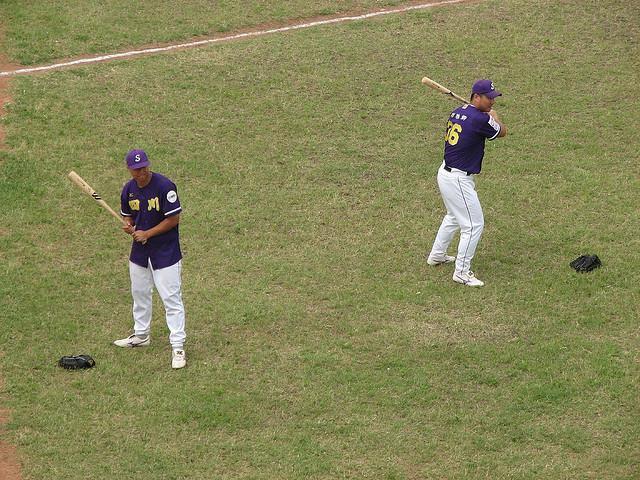How many bats are there?
Give a very brief answer. 2. How many people are there?
Give a very brief answer. 2. 